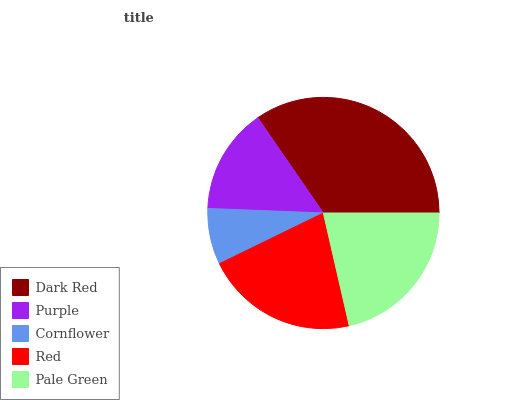Is Cornflower the minimum?
Answer yes or no. Yes. Is Dark Red the maximum?
Answer yes or no. Yes. Is Purple the minimum?
Answer yes or no. No. Is Purple the maximum?
Answer yes or no. No. Is Dark Red greater than Purple?
Answer yes or no. Yes. Is Purple less than Dark Red?
Answer yes or no. Yes. Is Purple greater than Dark Red?
Answer yes or no. No. Is Dark Red less than Purple?
Answer yes or no. No. Is Red the high median?
Answer yes or no. Yes. Is Red the low median?
Answer yes or no. Yes. Is Dark Red the high median?
Answer yes or no. No. Is Pale Green the low median?
Answer yes or no. No. 